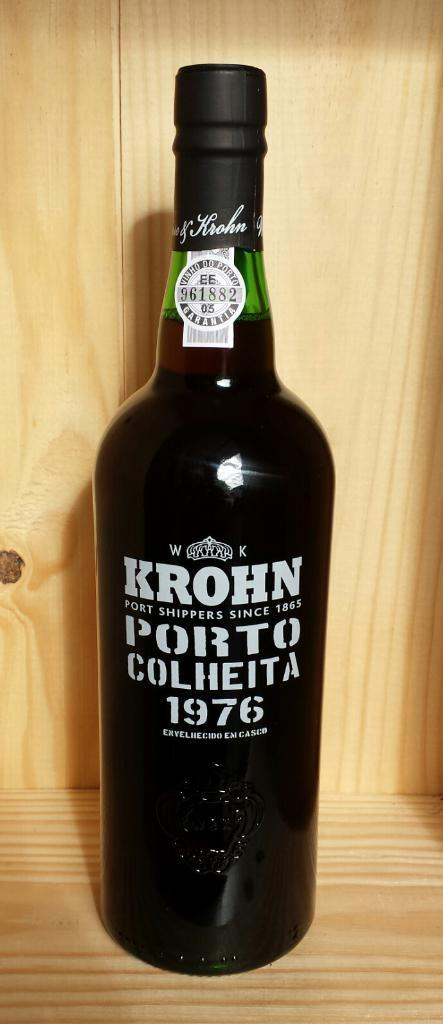<image>
Describe the image concisely. A bottle of Krohn sitting on a wooden shelf 